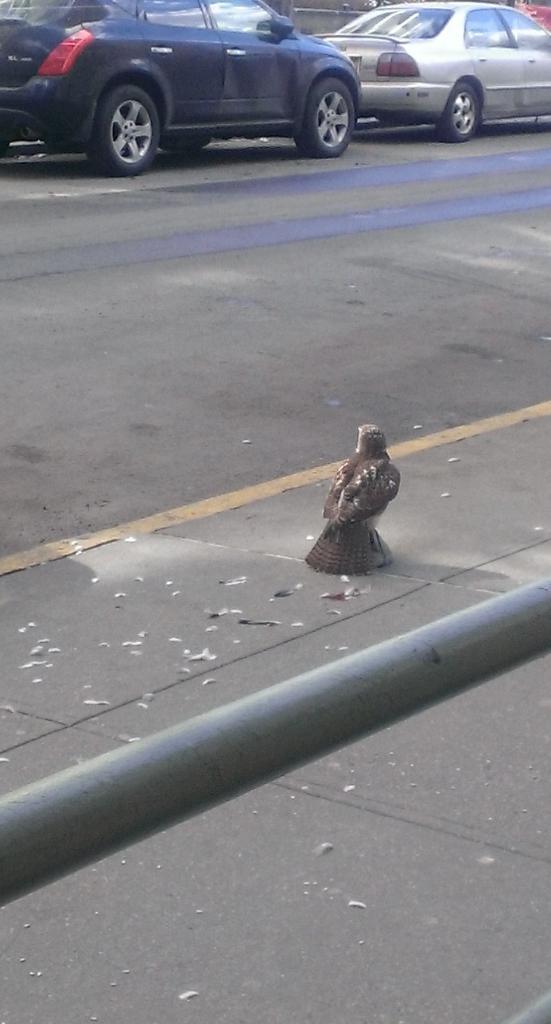In one or two sentences, can you explain what this image depicts? In this image there is a road on that road two cars are parked to a side, on the right side there is a bird on a footpath and there is an iron rod. 